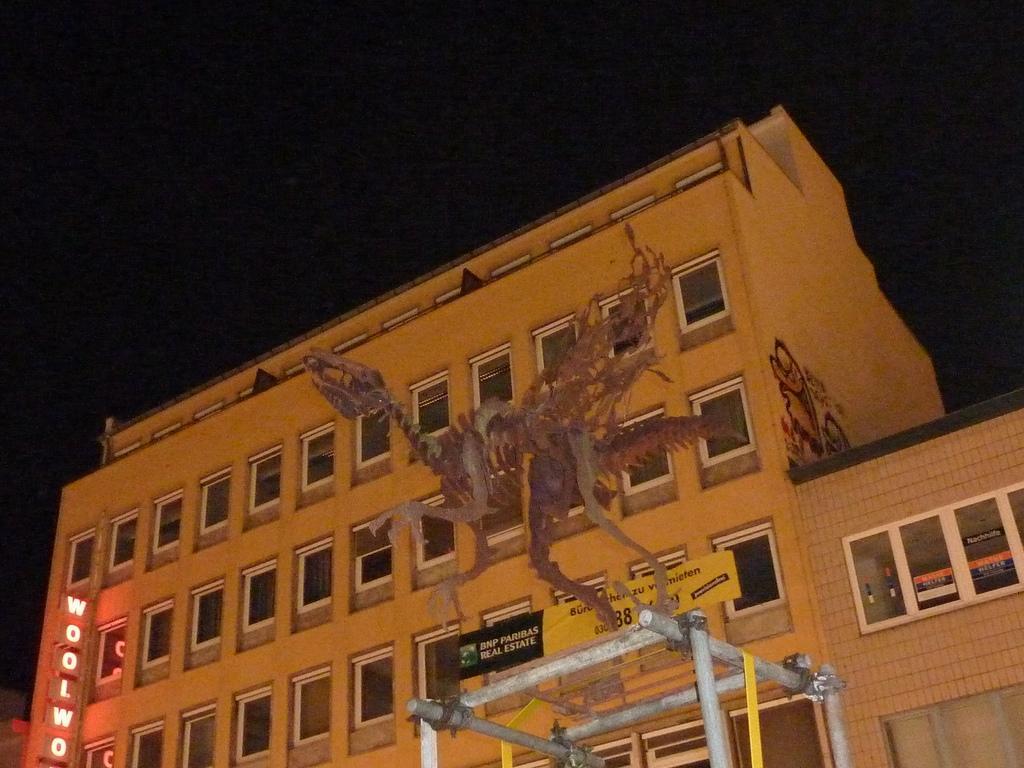How would you summarize this image in a sentence or two? In this image there is a skeleton of a dragon , and in the background there is a building with windows and a light board, there is sky. 